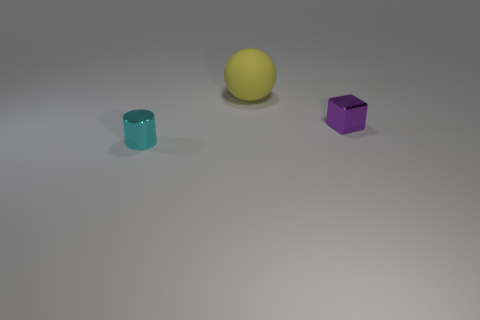Add 3 purple cubes. How many objects exist? 6 Subtract all cubes. How many objects are left? 2 Add 2 blue rubber balls. How many blue rubber balls exist? 2 Subtract 0 cyan cubes. How many objects are left? 3 Subtract all small gray metallic objects. Subtract all cyan cylinders. How many objects are left? 2 Add 1 tiny cubes. How many tiny cubes are left? 2 